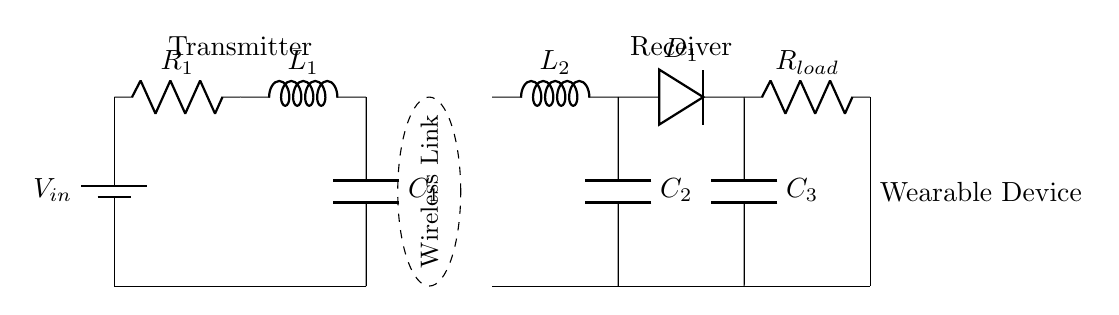What is the input voltage of the transmitter? The input voltage is denoted as V_in which is connected to the battery symbol in the circuit. The circuit does not specify a numerical value, so it remains as a variable.
Answer: V_in What type of components are represented by R_1, L_1, and C_1? R_1 is a resistor, L_1 is an inductor, and C_1 is a capacitor. These components are typically used for filtering and oscillating circuits, which is evident in their positions in the transmitter section of the circuit.
Answer: Resistor, Inductor, Capacitor How many capacitors are in the receiver part of the circuit? In the receiver part, there are two capacitors: C_2 and C_3. These are positioned in parallel to help regulate and smooth the rectified output.
Answer: 2 What is the role of the diode D_1 in the circuit? The diode D_1 allows current to flow in only one direction, converting the alternating current generated by the receiver to direct current suitable for charging the wearable device. Its placement within the circuit is indicative of its rectifying function.
Answer: Rectification Which component represents the load at the end of the circuit? The load is represented by R_load, which is connected in series after the diode and the capacitors in the receiver part. It signifies the wearable device that draws power from the circuit.
Answer: R_load What is the purpose of the wireless link indicated in the circuit? The wireless link serves to transfer power from the transmitter to the receiver without physical connections, allowing for contactless charging of the wearable device. It is represented as a dashed ellipse in the diagram to denote its absence of direct electrical connections.
Answer: Power transfer How does the frequency of operation relate to L_1 and C_1? The frequency of operation can be determined by the resonant frequency formula using L_1 and C_1. These elements in the transmitter form a resonant tank circuit, where the frequency at which resonance occurs is critical for efficient power transfer. Specifically, the resonant frequency is given by the expression 1 divided by the square root of the product of L_1 and C_1.
Answer: Resonant frequency calculation 